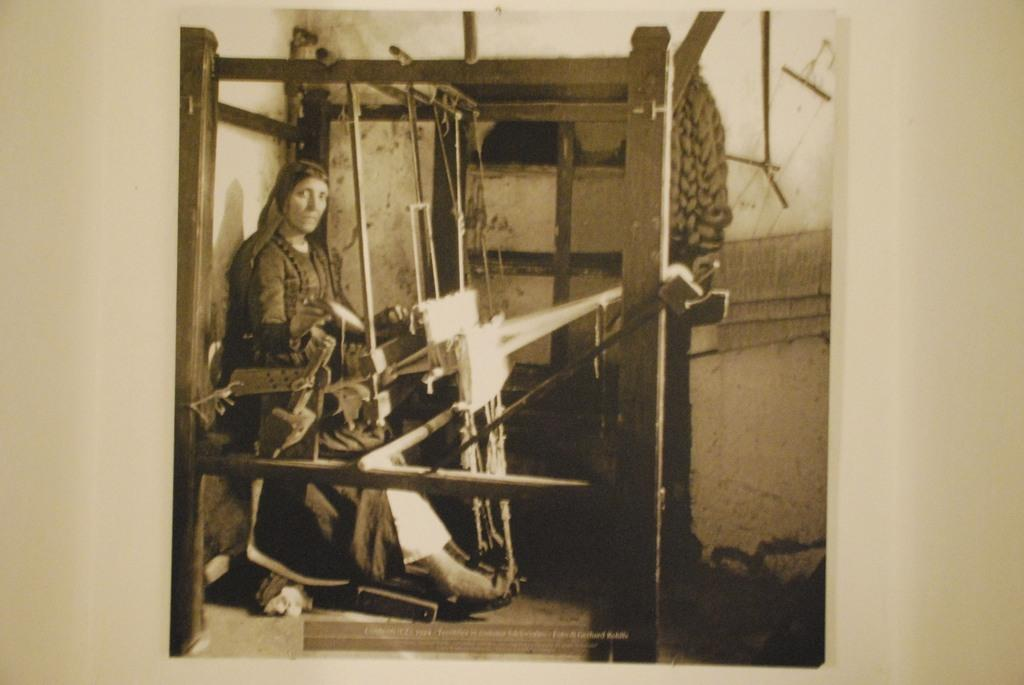What is the main subject of the image? The main subject of the image is a woman. Can you describe the wooden object in front of the woman? Unfortunately, the facts provided do not give any details about the wooden object. However, we can confirm that there is a wooden object in front of the woman. What type of insect can be seen crawling on the woman's shoulder in the image? There is no insect present on the woman's shoulder in the image. 